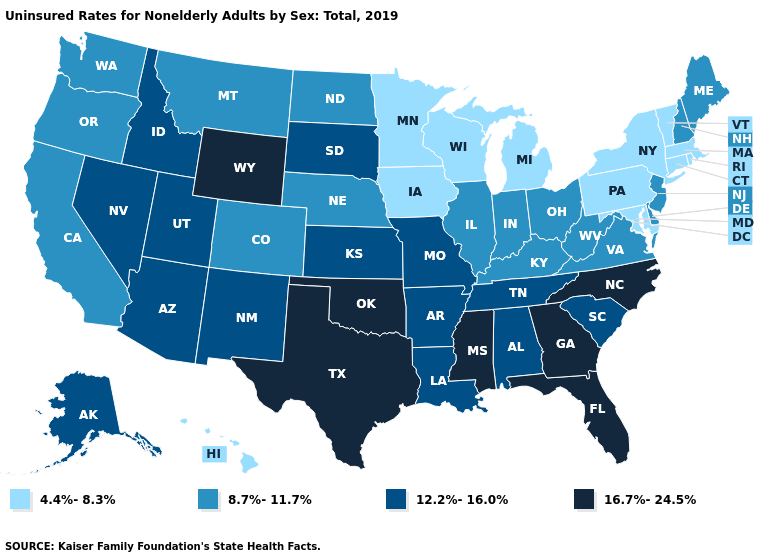Does the first symbol in the legend represent the smallest category?
Quick response, please. Yes. Name the states that have a value in the range 8.7%-11.7%?
Quick response, please. California, Colorado, Delaware, Illinois, Indiana, Kentucky, Maine, Montana, Nebraska, New Hampshire, New Jersey, North Dakota, Ohio, Oregon, Virginia, Washington, West Virginia. Does Iowa have the same value as Alabama?
Give a very brief answer. No. Name the states that have a value in the range 4.4%-8.3%?
Write a very short answer. Connecticut, Hawaii, Iowa, Maryland, Massachusetts, Michigan, Minnesota, New York, Pennsylvania, Rhode Island, Vermont, Wisconsin. What is the value of Wyoming?
Keep it brief. 16.7%-24.5%. Which states have the highest value in the USA?
Quick response, please. Florida, Georgia, Mississippi, North Carolina, Oklahoma, Texas, Wyoming. What is the highest value in the USA?
Give a very brief answer. 16.7%-24.5%. What is the lowest value in the USA?
Concise answer only. 4.4%-8.3%. Among the states that border Massachusetts , does New Hampshire have the highest value?
Write a very short answer. Yes. Name the states that have a value in the range 8.7%-11.7%?
Short answer required. California, Colorado, Delaware, Illinois, Indiana, Kentucky, Maine, Montana, Nebraska, New Hampshire, New Jersey, North Dakota, Ohio, Oregon, Virginia, Washington, West Virginia. Name the states that have a value in the range 8.7%-11.7%?
Be succinct. California, Colorado, Delaware, Illinois, Indiana, Kentucky, Maine, Montana, Nebraska, New Hampshire, New Jersey, North Dakota, Ohio, Oregon, Virginia, Washington, West Virginia. What is the value of New York?
Concise answer only. 4.4%-8.3%. Does the first symbol in the legend represent the smallest category?
Quick response, please. Yes. Is the legend a continuous bar?
Give a very brief answer. No. Name the states that have a value in the range 4.4%-8.3%?
Give a very brief answer. Connecticut, Hawaii, Iowa, Maryland, Massachusetts, Michigan, Minnesota, New York, Pennsylvania, Rhode Island, Vermont, Wisconsin. 